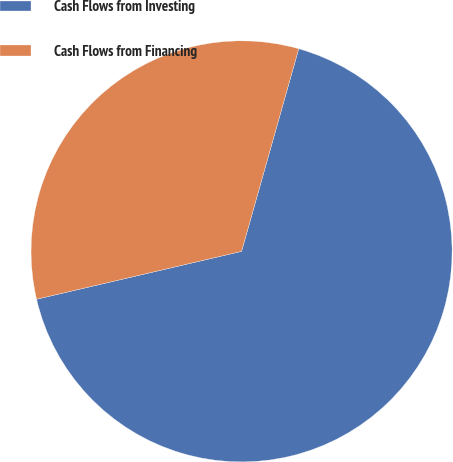<chart> <loc_0><loc_0><loc_500><loc_500><pie_chart><fcel>Cash Flows from Investing<fcel>Cash Flows from Financing<nl><fcel>66.97%<fcel>33.03%<nl></chart> 